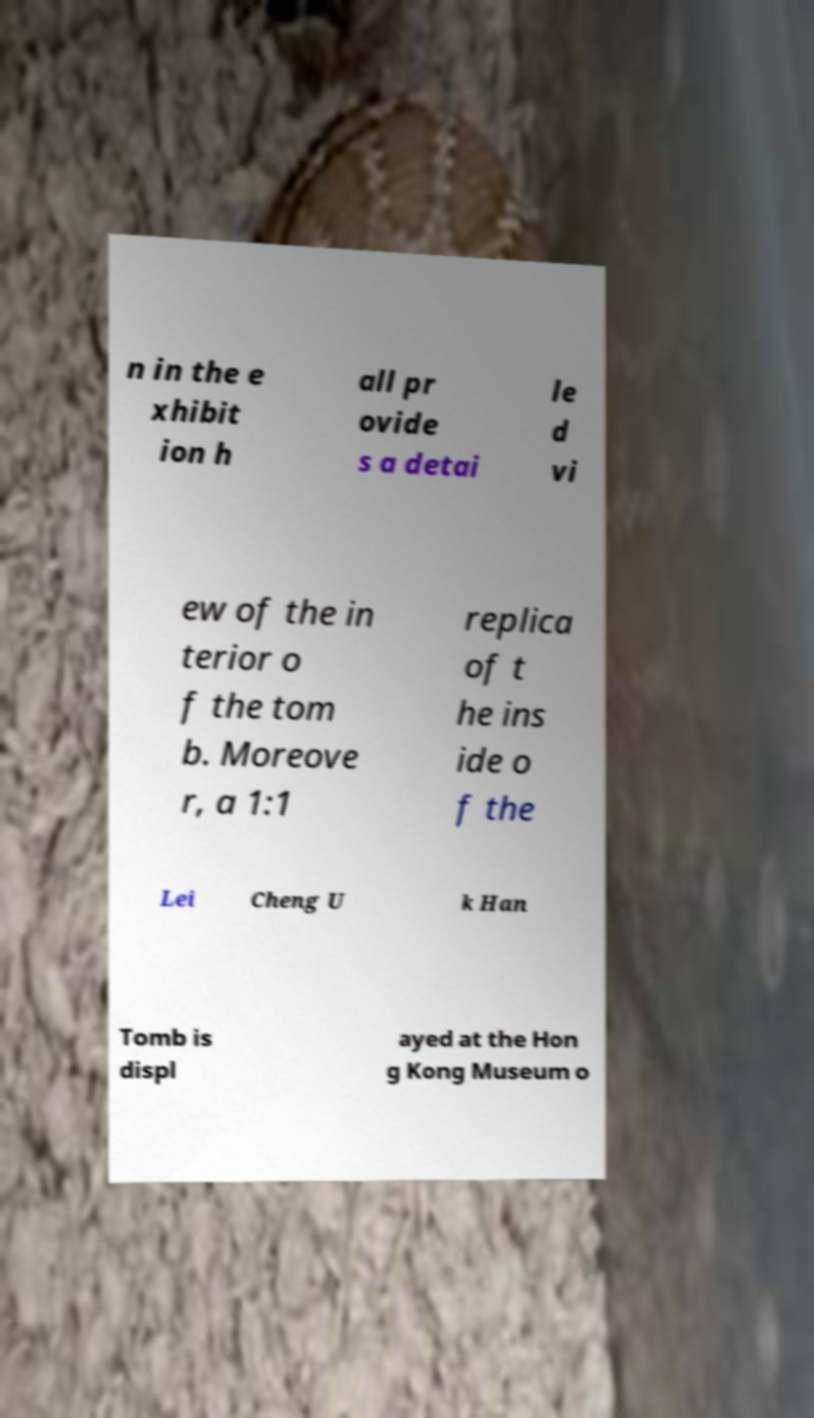Can you accurately transcribe the text from the provided image for me? n in the e xhibit ion h all pr ovide s a detai le d vi ew of the in terior o f the tom b. Moreove r, a 1:1 replica of t he ins ide o f the Lei Cheng U k Han Tomb is displ ayed at the Hon g Kong Museum o 